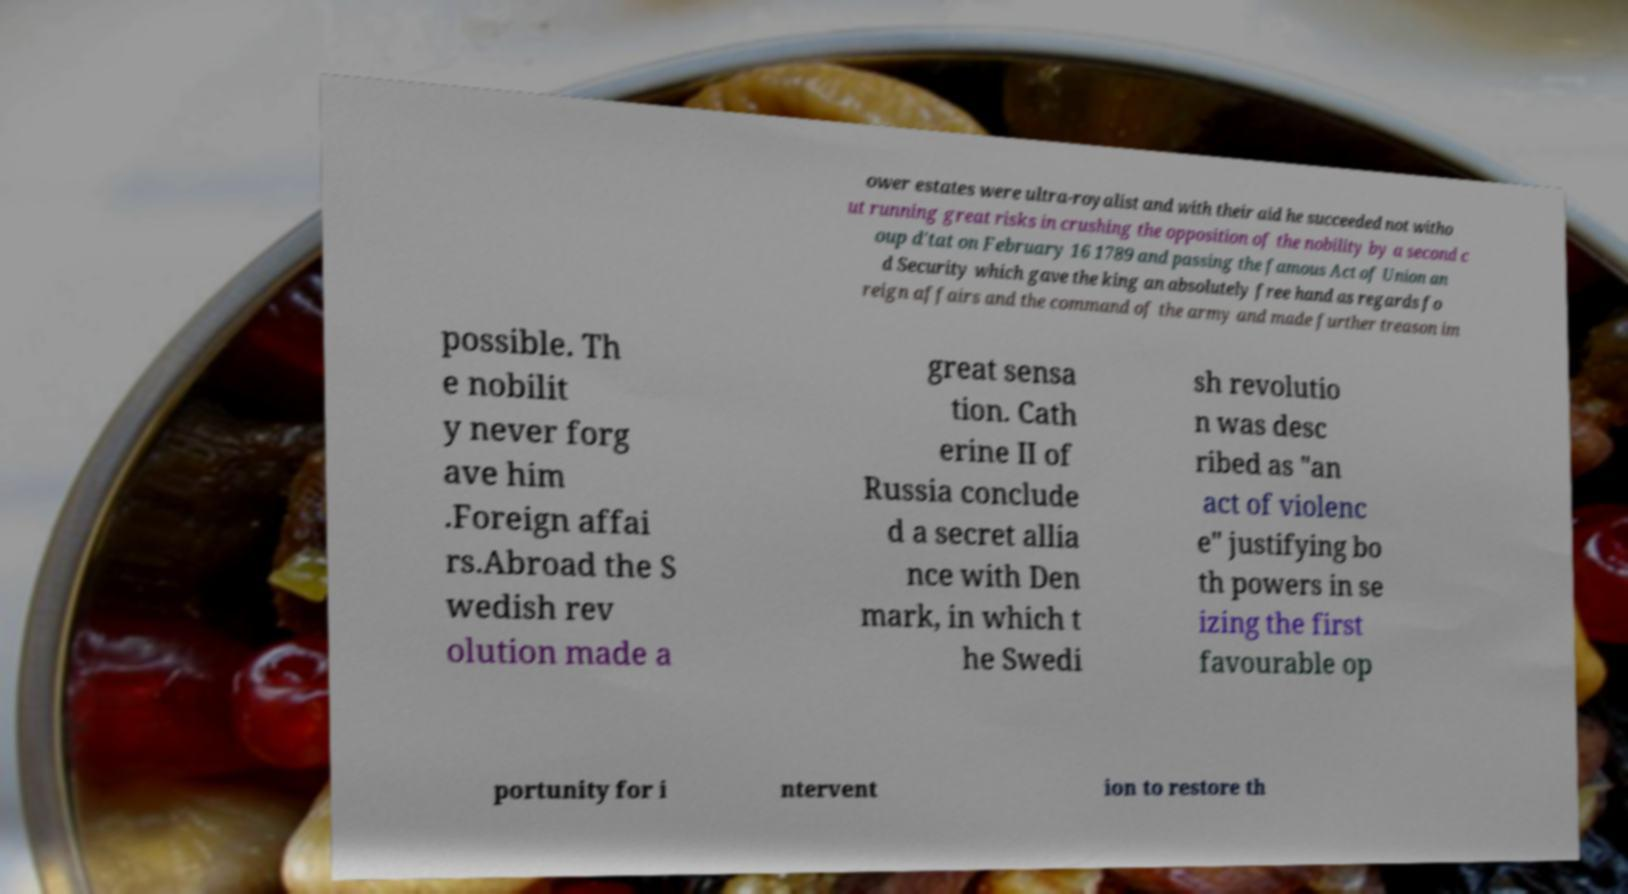For documentation purposes, I need the text within this image transcribed. Could you provide that? ower estates were ultra-royalist and with their aid he succeeded not witho ut running great risks in crushing the opposition of the nobility by a second c oup d'tat on February 16 1789 and passing the famous Act of Union an d Security which gave the king an absolutely free hand as regards fo reign affairs and the command of the army and made further treason im possible. Th e nobilit y never forg ave him .Foreign affai rs.Abroad the S wedish rev olution made a great sensa tion. Cath erine II of Russia conclude d a secret allia nce with Den mark, in which t he Swedi sh revolutio n was desc ribed as "an act of violenc e" justifying bo th powers in se izing the first favourable op portunity for i ntervent ion to restore th 